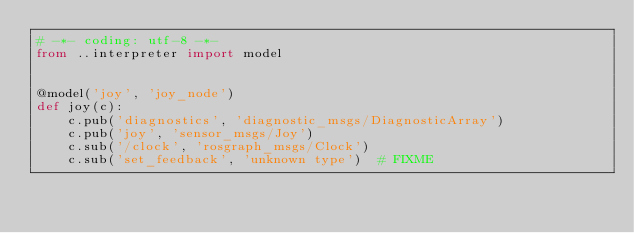<code> <loc_0><loc_0><loc_500><loc_500><_Python_># -*- coding: utf-8 -*-
from ..interpreter import model


@model('joy', 'joy_node')
def joy(c):
    c.pub('diagnostics', 'diagnostic_msgs/DiagnosticArray')
    c.pub('joy', 'sensor_msgs/Joy')
    c.sub('/clock', 'rosgraph_msgs/Clock')
    c.sub('set_feedback', 'unknown type')  # FIXME
</code> 